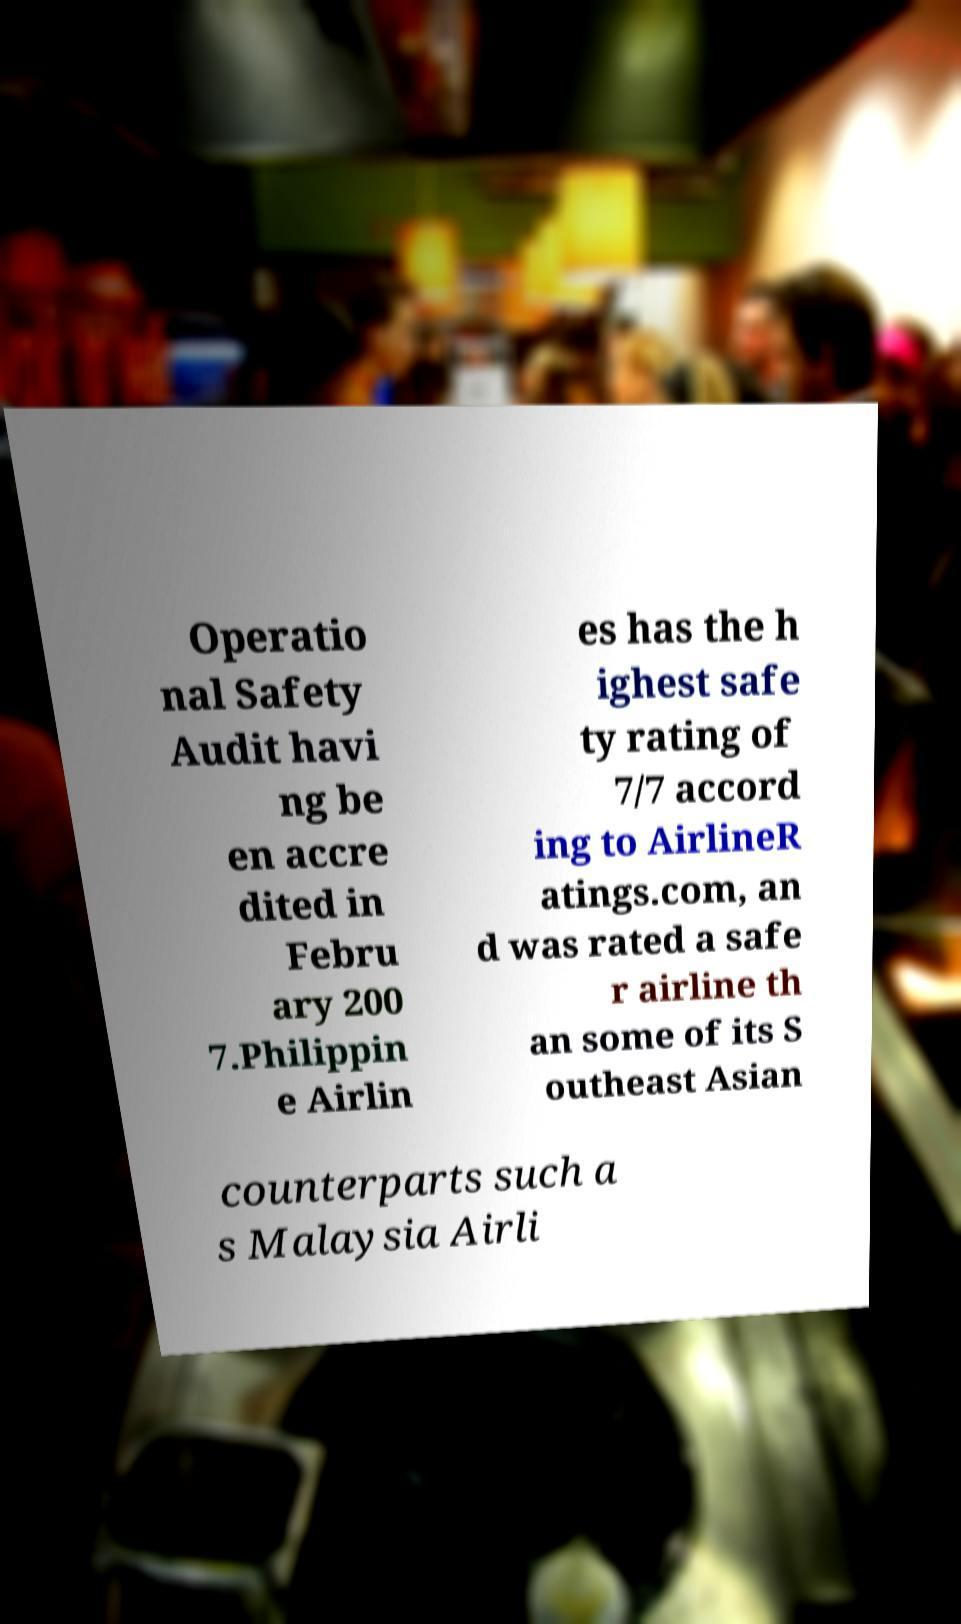Can you read and provide the text displayed in the image?This photo seems to have some interesting text. Can you extract and type it out for me? Operatio nal Safety Audit havi ng be en accre dited in Febru ary 200 7.Philippin e Airlin es has the h ighest safe ty rating of 7/7 accord ing to AirlineR atings.com, an d was rated a safe r airline th an some of its S outheast Asian counterparts such a s Malaysia Airli 